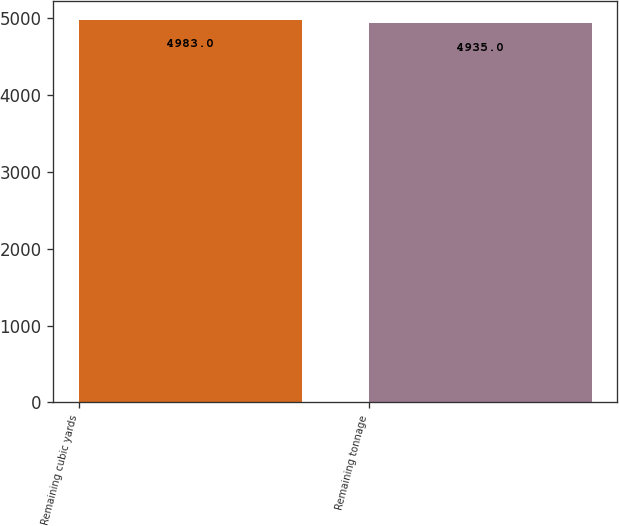<chart> <loc_0><loc_0><loc_500><loc_500><bar_chart><fcel>Remaining cubic yards<fcel>Remaining tonnage<nl><fcel>4983<fcel>4935<nl></chart> 